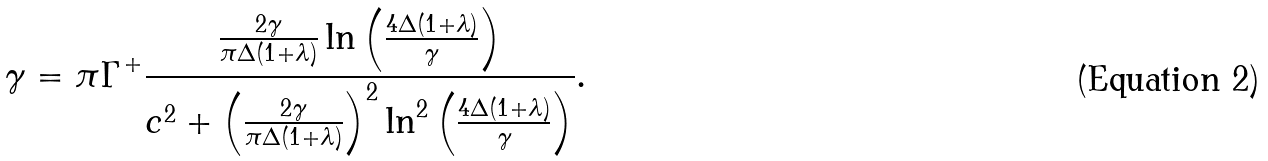Convert formula to latex. <formula><loc_0><loc_0><loc_500><loc_500>\gamma = \pi \Gamma ^ { + } \frac { \frac { 2 \gamma } { \pi \Delta ( 1 + \lambda ) } \ln \left ( \frac { 4 \Delta ( 1 + \lambda ) } { \gamma } \right ) } { c ^ { 2 } + \left ( \frac { 2 \gamma } { \pi \Delta ( 1 + \lambda ) } \right ) ^ { 2 } \ln ^ { 2 } \left ( \frac { 4 \Delta ( 1 + \lambda ) } { \gamma } \right ) } .</formula> 